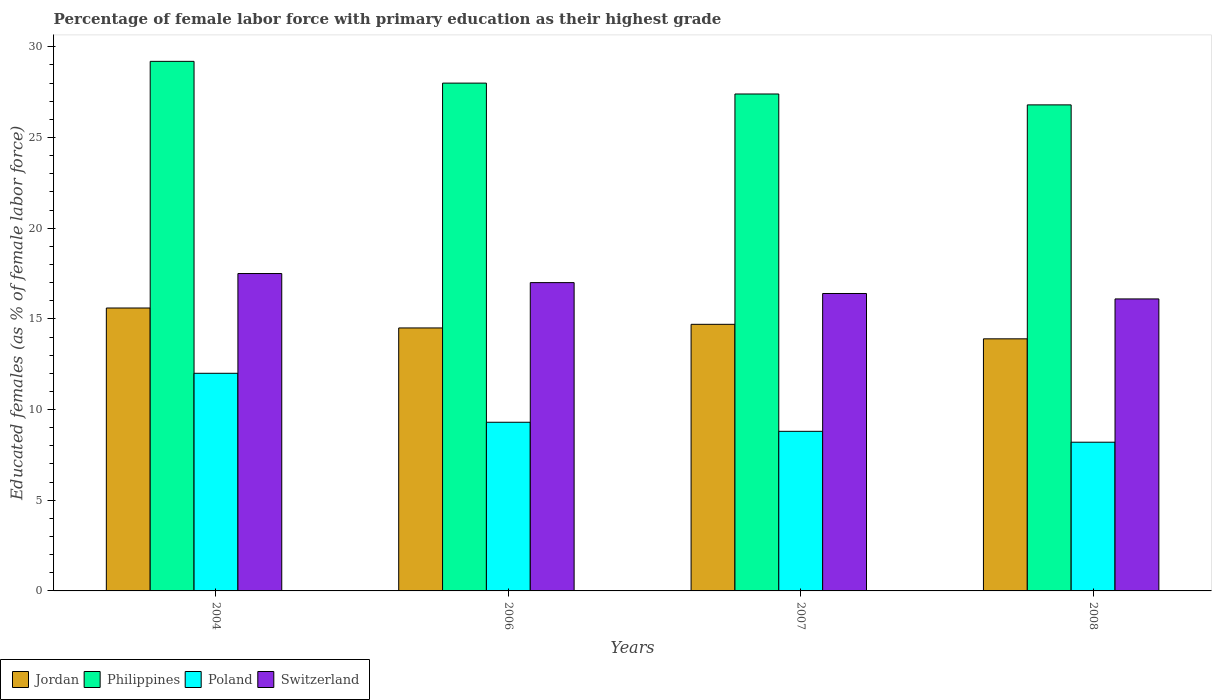How many different coloured bars are there?
Make the answer very short. 4. What is the label of the 2nd group of bars from the left?
Your response must be concise. 2006. In how many cases, is the number of bars for a given year not equal to the number of legend labels?
Your answer should be very brief. 0. What is the percentage of female labor force with primary education in Poland in 2006?
Your answer should be very brief. 9.3. Across all years, what is the maximum percentage of female labor force with primary education in Philippines?
Offer a terse response. 29.2. Across all years, what is the minimum percentage of female labor force with primary education in Philippines?
Ensure brevity in your answer.  26.8. In which year was the percentage of female labor force with primary education in Poland maximum?
Your response must be concise. 2004. In which year was the percentage of female labor force with primary education in Jordan minimum?
Offer a very short reply. 2008. What is the total percentage of female labor force with primary education in Switzerland in the graph?
Provide a succinct answer. 67. What is the difference between the percentage of female labor force with primary education in Philippines in 2004 and that in 2007?
Offer a terse response. 1.8. What is the difference between the percentage of female labor force with primary education in Jordan in 2008 and the percentage of female labor force with primary education in Poland in 2004?
Provide a short and direct response. 1.9. What is the average percentage of female labor force with primary education in Jordan per year?
Your response must be concise. 14.67. In the year 2008, what is the difference between the percentage of female labor force with primary education in Poland and percentage of female labor force with primary education in Switzerland?
Your answer should be compact. -7.9. In how many years, is the percentage of female labor force with primary education in Jordan greater than 5 %?
Offer a very short reply. 4. What is the ratio of the percentage of female labor force with primary education in Switzerland in 2007 to that in 2008?
Ensure brevity in your answer.  1.02. Is the difference between the percentage of female labor force with primary education in Poland in 2004 and 2007 greater than the difference between the percentage of female labor force with primary education in Switzerland in 2004 and 2007?
Offer a terse response. Yes. What is the difference between the highest and the second highest percentage of female labor force with primary education in Poland?
Your response must be concise. 2.7. What is the difference between the highest and the lowest percentage of female labor force with primary education in Philippines?
Make the answer very short. 2.4. In how many years, is the percentage of female labor force with primary education in Switzerland greater than the average percentage of female labor force with primary education in Switzerland taken over all years?
Ensure brevity in your answer.  2. Is it the case that in every year, the sum of the percentage of female labor force with primary education in Jordan and percentage of female labor force with primary education in Poland is greater than the sum of percentage of female labor force with primary education in Switzerland and percentage of female labor force with primary education in Philippines?
Your answer should be compact. No. What does the 1st bar from the left in 2004 represents?
Keep it short and to the point. Jordan. What does the 4th bar from the right in 2006 represents?
Your answer should be very brief. Jordan. Is it the case that in every year, the sum of the percentage of female labor force with primary education in Jordan and percentage of female labor force with primary education in Poland is greater than the percentage of female labor force with primary education in Philippines?
Make the answer very short. No. Are all the bars in the graph horizontal?
Keep it short and to the point. No. Are the values on the major ticks of Y-axis written in scientific E-notation?
Your answer should be compact. No. Where does the legend appear in the graph?
Make the answer very short. Bottom left. How many legend labels are there?
Keep it short and to the point. 4. How are the legend labels stacked?
Your answer should be very brief. Horizontal. What is the title of the graph?
Offer a very short reply. Percentage of female labor force with primary education as their highest grade. What is the label or title of the Y-axis?
Your response must be concise. Educated females (as % of female labor force). What is the Educated females (as % of female labor force) in Jordan in 2004?
Give a very brief answer. 15.6. What is the Educated females (as % of female labor force) in Philippines in 2004?
Offer a terse response. 29.2. What is the Educated females (as % of female labor force) of Poland in 2004?
Your response must be concise. 12. What is the Educated females (as % of female labor force) in Switzerland in 2004?
Keep it short and to the point. 17.5. What is the Educated females (as % of female labor force) in Jordan in 2006?
Your answer should be very brief. 14.5. What is the Educated females (as % of female labor force) of Poland in 2006?
Ensure brevity in your answer.  9.3. What is the Educated females (as % of female labor force) of Jordan in 2007?
Keep it short and to the point. 14.7. What is the Educated females (as % of female labor force) in Philippines in 2007?
Give a very brief answer. 27.4. What is the Educated females (as % of female labor force) in Poland in 2007?
Your answer should be very brief. 8.8. What is the Educated females (as % of female labor force) in Switzerland in 2007?
Offer a terse response. 16.4. What is the Educated females (as % of female labor force) in Jordan in 2008?
Your response must be concise. 13.9. What is the Educated females (as % of female labor force) in Philippines in 2008?
Your response must be concise. 26.8. What is the Educated females (as % of female labor force) of Poland in 2008?
Give a very brief answer. 8.2. What is the Educated females (as % of female labor force) of Switzerland in 2008?
Offer a very short reply. 16.1. Across all years, what is the maximum Educated females (as % of female labor force) in Jordan?
Your answer should be compact. 15.6. Across all years, what is the maximum Educated females (as % of female labor force) of Philippines?
Your answer should be compact. 29.2. Across all years, what is the maximum Educated females (as % of female labor force) in Poland?
Make the answer very short. 12. Across all years, what is the minimum Educated females (as % of female labor force) in Jordan?
Your answer should be very brief. 13.9. Across all years, what is the minimum Educated females (as % of female labor force) of Philippines?
Provide a short and direct response. 26.8. Across all years, what is the minimum Educated females (as % of female labor force) in Poland?
Your response must be concise. 8.2. Across all years, what is the minimum Educated females (as % of female labor force) in Switzerland?
Your response must be concise. 16.1. What is the total Educated females (as % of female labor force) in Jordan in the graph?
Your answer should be compact. 58.7. What is the total Educated females (as % of female labor force) of Philippines in the graph?
Provide a succinct answer. 111.4. What is the total Educated females (as % of female labor force) of Poland in the graph?
Your response must be concise. 38.3. What is the difference between the Educated females (as % of female labor force) of Jordan in 2004 and that in 2007?
Your response must be concise. 0.9. What is the difference between the Educated females (as % of female labor force) in Poland in 2004 and that in 2007?
Offer a very short reply. 3.2. What is the difference between the Educated females (as % of female labor force) in Switzerland in 2004 and that in 2007?
Keep it short and to the point. 1.1. What is the difference between the Educated females (as % of female labor force) of Jordan in 2004 and that in 2008?
Your answer should be very brief. 1.7. What is the difference between the Educated females (as % of female labor force) in Philippines in 2004 and that in 2008?
Give a very brief answer. 2.4. What is the difference between the Educated females (as % of female labor force) of Poland in 2004 and that in 2008?
Keep it short and to the point. 3.8. What is the difference between the Educated females (as % of female labor force) in Switzerland in 2004 and that in 2008?
Provide a succinct answer. 1.4. What is the difference between the Educated females (as % of female labor force) in Jordan in 2006 and that in 2007?
Provide a short and direct response. -0.2. What is the difference between the Educated females (as % of female labor force) in Philippines in 2006 and that in 2007?
Your answer should be compact. 0.6. What is the difference between the Educated females (as % of female labor force) in Poland in 2006 and that in 2007?
Provide a short and direct response. 0.5. What is the difference between the Educated females (as % of female labor force) of Jordan in 2006 and that in 2008?
Keep it short and to the point. 0.6. What is the difference between the Educated females (as % of female labor force) in Philippines in 2007 and that in 2008?
Ensure brevity in your answer.  0.6. What is the difference between the Educated females (as % of female labor force) in Poland in 2007 and that in 2008?
Your answer should be very brief. 0.6. What is the difference between the Educated females (as % of female labor force) in Jordan in 2004 and the Educated females (as % of female labor force) in Switzerland in 2006?
Keep it short and to the point. -1.4. What is the difference between the Educated females (as % of female labor force) in Philippines in 2004 and the Educated females (as % of female labor force) in Poland in 2006?
Your answer should be very brief. 19.9. What is the difference between the Educated females (as % of female labor force) in Jordan in 2004 and the Educated females (as % of female labor force) in Philippines in 2007?
Keep it short and to the point. -11.8. What is the difference between the Educated females (as % of female labor force) of Jordan in 2004 and the Educated females (as % of female labor force) of Poland in 2007?
Your answer should be compact. 6.8. What is the difference between the Educated females (as % of female labor force) of Philippines in 2004 and the Educated females (as % of female labor force) of Poland in 2007?
Keep it short and to the point. 20.4. What is the difference between the Educated females (as % of female labor force) in Jordan in 2004 and the Educated females (as % of female labor force) in Poland in 2008?
Your answer should be very brief. 7.4. What is the difference between the Educated females (as % of female labor force) in Jordan in 2004 and the Educated females (as % of female labor force) in Switzerland in 2008?
Provide a succinct answer. -0.5. What is the difference between the Educated females (as % of female labor force) in Poland in 2004 and the Educated females (as % of female labor force) in Switzerland in 2008?
Provide a succinct answer. -4.1. What is the difference between the Educated females (as % of female labor force) in Poland in 2006 and the Educated females (as % of female labor force) in Switzerland in 2007?
Your answer should be compact. -7.1. What is the difference between the Educated females (as % of female labor force) of Jordan in 2006 and the Educated females (as % of female labor force) of Switzerland in 2008?
Keep it short and to the point. -1.6. What is the difference between the Educated females (as % of female labor force) of Philippines in 2006 and the Educated females (as % of female labor force) of Poland in 2008?
Offer a very short reply. 19.8. What is the difference between the Educated females (as % of female labor force) of Philippines in 2006 and the Educated females (as % of female labor force) of Switzerland in 2008?
Give a very brief answer. 11.9. What is the difference between the Educated females (as % of female labor force) of Jordan in 2007 and the Educated females (as % of female labor force) of Philippines in 2008?
Ensure brevity in your answer.  -12.1. What is the difference between the Educated females (as % of female labor force) of Jordan in 2007 and the Educated females (as % of female labor force) of Poland in 2008?
Ensure brevity in your answer.  6.5. What is the difference between the Educated females (as % of female labor force) of Philippines in 2007 and the Educated females (as % of female labor force) of Poland in 2008?
Provide a succinct answer. 19.2. What is the difference between the Educated females (as % of female labor force) in Poland in 2007 and the Educated females (as % of female labor force) in Switzerland in 2008?
Your answer should be very brief. -7.3. What is the average Educated females (as % of female labor force) in Jordan per year?
Provide a succinct answer. 14.68. What is the average Educated females (as % of female labor force) of Philippines per year?
Keep it short and to the point. 27.85. What is the average Educated females (as % of female labor force) in Poland per year?
Provide a succinct answer. 9.57. What is the average Educated females (as % of female labor force) in Switzerland per year?
Your answer should be very brief. 16.75. In the year 2004, what is the difference between the Educated females (as % of female labor force) of Jordan and Educated females (as % of female labor force) of Philippines?
Make the answer very short. -13.6. In the year 2004, what is the difference between the Educated females (as % of female labor force) of Jordan and Educated females (as % of female labor force) of Poland?
Your response must be concise. 3.6. In the year 2004, what is the difference between the Educated females (as % of female labor force) of Jordan and Educated females (as % of female labor force) of Switzerland?
Your answer should be very brief. -1.9. In the year 2004, what is the difference between the Educated females (as % of female labor force) of Philippines and Educated females (as % of female labor force) of Switzerland?
Offer a terse response. 11.7. In the year 2004, what is the difference between the Educated females (as % of female labor force) in Poland and Educated females (as % of female labor force) in Switzerland?
Your answer should be very brief. -5.5. In the year 2006, what is the difference between the Educated females (as % of female labor force) of Jordan and Educated females (as % of female labor force) of Poland?
Give a very brief answer. 5.2. In the year 2006, what is the difference between the Educated females (as % of female labor force) of Jordan and Educated females (as % of female labor force) of Switzerland?
Ensure brevity in your answer.  -2.5. In the year 2006, what is the difference between the Educated females (as % of female labor force) of Philippines and Educated females (as % of female labor force) of Poland?
Your answer should be compact. 18.7. In the year 2007, what is the difference between the Educated females (as % of female labor force) in Jordan and Educated females (as % of female labor force) in Poland?
Offer a terse response. 5.9. In the year 2007, what is the difference between the Educated females (as % of female labor force) of Philippines and Educated females (as % of female labor force) of Poland?
Your response must be concise. 18.6. In the year 2007, what is the difference between the Educated females (as % of female labor force) in Philippines and Educated females (as % of female labor force) in Switzerland?
Provide a short and direct response. 11. What is the ratio of the Educated females (as % of female labor force) of Jordan in 2004 to that in 2006?
Give a very brief answer. 1.08. What is the ratio of the Educated females (as % of female labor force) in Philippines in 2004 to that in 2006?
Give a very brief answer. 1.04. What is the ratio of the Educated females (as % of female labor force) in Poland in 2004 to that in 2006?
Keep it short and to the point. 1.29. What is the ratio of the Educated females (as % of female labor force) in Switzerland in 2004 to that in 2006?
Offer a terse response. 1.03. What is the ratio of the Educated females (as % of female labor force) of Jordan in 2004 to that in 2007?
Ensure brevity in your answer.  1.06. What is the ratio of the Educated females (as % of female labor force) of Philippines in 2004 to that in 2007?
Offer a very short reply. 1.07. What is the ratio of the Educated females (as % of female labor force) of Poland in 2004 to that in 2007?
Provide a succinct answer. 1.36. What is the ratio of the Educated females (as % of female labor force) of Switzerland in 2004 to that in 2007?
Your answer should be very brief. 1.07. What is the ratio of the Educated females (as % of female labor force) of Jordan in 2004 to that in 2008?
Ensure brevity in your answer.  1.12. What is the ratio of the Educated females (as % of female labor force) of Philippines in 2004 to that in 2008?
Give a very brief answer. 1.09. What is the ratio of the Educated females (as % of female labor force) of Poland in 2004 to that in 2008?
Offer a very short reply. 1.46. What is the ratio of the Educated females (as % of female labor force) in Switzerland in 2004 to that in 2008?
Offer a terse response. 1.09. What is the ratio of the Educated females (as % of female labor force) in Jordan in 2006 to that in 2007?
Give a very brief answer. 0.99. What is the ratio of the Educated females (as % of female labor force) in Philippines in 2006 to that in 2007?
Ensure brevity in your answer.  1.02. What is the ratio of the Educated females (as % of female labor force) in Poland in 2006 to that in 2007?
Your response must be concise. 1.06. What is the ratio of the Educated females (as % of female labor force) of Switzerland in 2006 to that in 2007?
Your answer should be compact. 1.04. What is the ratio of the Educated females (as % of female labor force) of Jordan in 2006 to that in 2008?
Give a very brief answer. 1.04. What is the ratio of the Educated females (as % of female labor force) of Philippines in 2006 to that in 2008?
Provide a succinct answer. 1.04. What is the ratio of the Educated females (as % of female labor force) of Poland in 2006 to that in 2008?
Your response must be concise. 1.13. What is the ratio of the Educated females (as % of female labor force) in Switzerland in 2006 to that in 2008?
Your answer should be compact. 1.06. What is the ratio of the Educated females (as % of female labor force) of Jordan in 2007 to that in 2008?
Keep it short and to the point. 1.06. What is the ratio of the Educated females (as % of female labor force) of Philippines in 2007 to that in 2008?
Your response must be concise. 1.02. What is the ratio of the Educated females (as % of female labor force) in Poland in 2007 to that in 2008?
Your answer should be compact. 1.07. What is the ratio of the Educated females (as % of female labor force) in Switzerland in 2007 to that in 2008?
Your response must be concise. 1.02. What is the difference between the highest and the second highest Educated females (as % of female labor force) in Philippines?
Offer a terse response. 1.2. What is the difference between the highest and the second highest Educated females (as % of female labor force) in Switzerland?
Your response must be concise. 0.5. What is the difference between the highest and the lowest Educated females (as % of female labor force) in Jordan?
Your response must be concise. 1.7. What is the difference between the highest and the lowest Educated females (as % of female labor force) in Philippines?
Make the answer very short. 2.4. What is the difference between the highest and the lowest Educated females (as % of female labor force) of Poland?
Your response must be concise. 3.8. What is the difference between the highest and the lowest Educated females (as % of female labor force) of Switzerland?
Your answer should be compact. 1.4. 